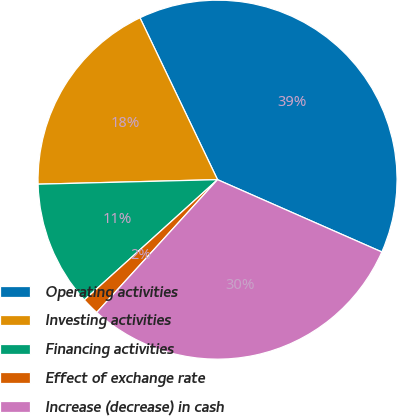<chart> <loc_0><loc_0><loc_500><loc_500><pie_chart><fcel>Operating activities<fcel>Investing activities<fcel>Financing activities<fcel>Effect of exchange rate<fcel>Increase (decrease) in cash<nl><fcel>38.71%<fcel>18.29%<fcel>11.29%<fcel>1.56%<fcel>30.15%<nl></chart> 